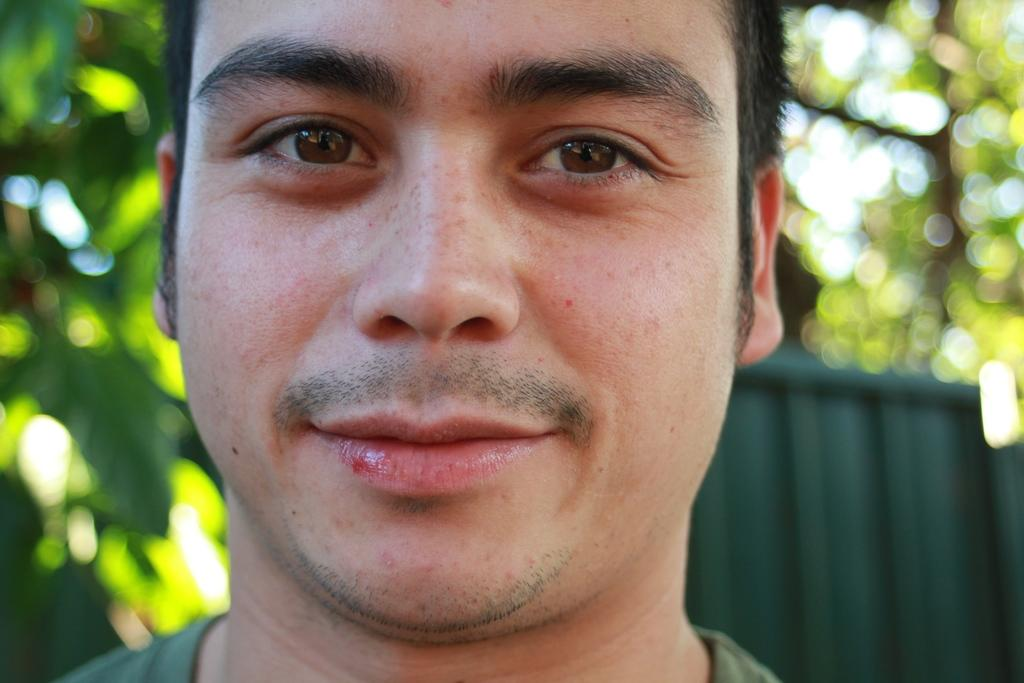Who is the main subject in the foreground of the image? There is a man in the foreground of the image. What type of natural scenery can be seen in the background of the image? There are trees in the background of the image. Can you describe the object in the background that resembles a container? Yes, there is an object in the background that looks like a container. What type of reaction can be seen from the man in the image? There is no indication of a reaction from the man in the image, as his facial expression or body language is not visible. 